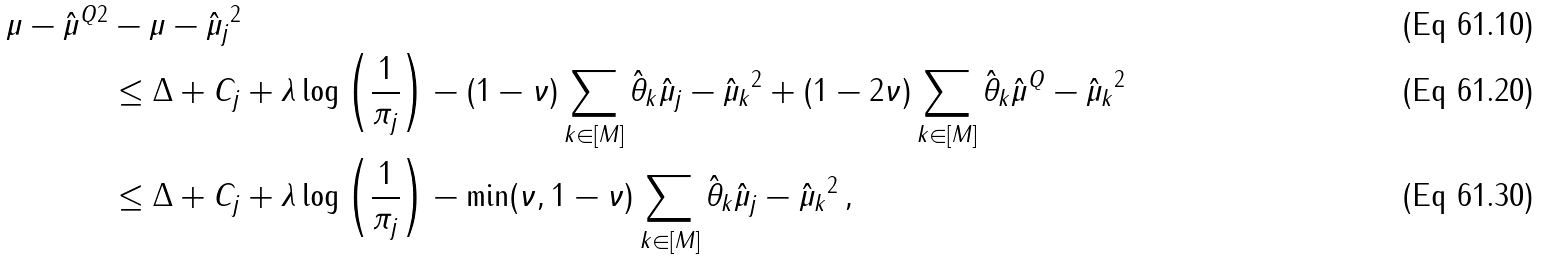Convert formula to latex. <formula><loc_0><loc_0><loc_500><loc_500>\| \mu - \hat { \mu } ^ { Q } \| ^ { 2 } & - \| \mu - \hat { \mu } _ { j } \| ^ { 2 } \\ & \leq \Delta + C _ { j } + \lambda \log \left ( \frac { 1 } { \pi _ { j } } \right ) - ( 1 - \nu ) \sum _ { k \in [ M ] } \hat { \theta } _ { k } \| \hat { \mu } _ { j } - \hat { \mu } _ { k } \| ^ { 2 } + ( 1 - 2 \nu ) \sum _ { k \in [ M ] } \hat { \theta } _ { k } \| \hat { \mu } ^ { Q } - \hat { \mu } _ { k } \| ^ { 2 } \\ & \leq \Delta + C _ { j } + \lambda \log \left ( \frac { 1 } { \pi _ { j } } \right ) - \min ( \nu , 1 - \nu ) \sum _ { k \in [ M ] } \hat { \theta } _ { k } \| \hat { \mu } _ { j } - \hat { \mu } _ { k } \| ^ { 2 } \, ,</formula> 